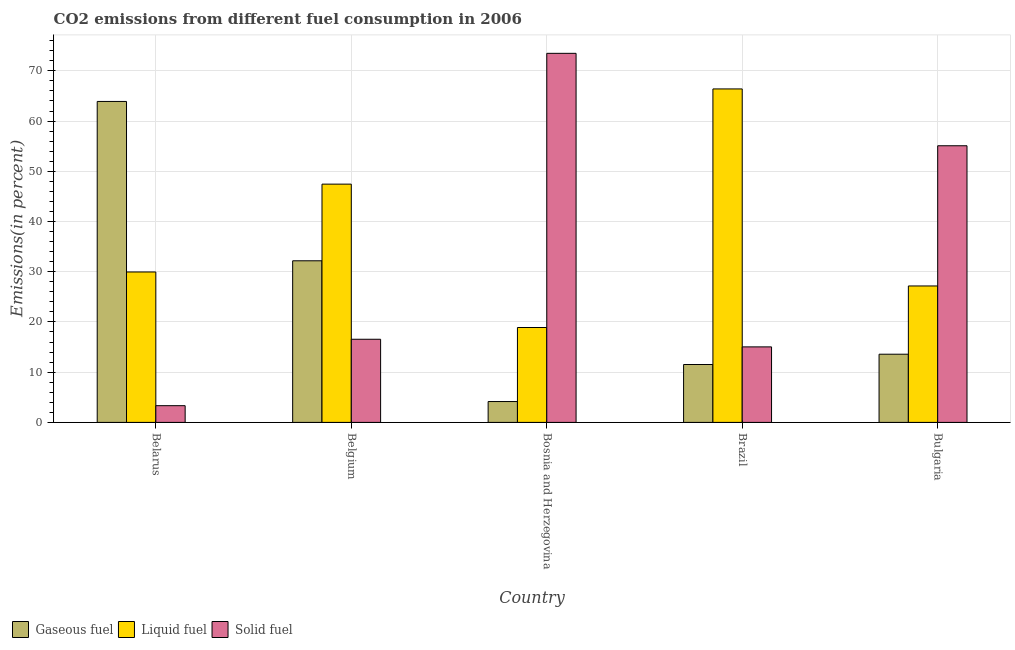How many groups of bars are there?
Your response must be concise. 5. Are the number of bars per tick equal to the number of legend labels?
Provide a short and direct response. Yes. Are the number of bars on each tick of the X-axis equal?
Provide a succinct answer. Yes. What is the label of the 1st group of bars from the left?
Provide a succinct answer. Belarus. In how many cases, is the number of bars for a given country not equal to the number of legend labels?
Keep it short and to the point. 0. What is the percentage of gaseous fuel emission in Belarus?
Your answer should be compact. 63.9. Across all countries, what is the maximum percentage of solid fuel emission?
Make the answer very short. 73.49. Across all countries, what is the minimum percentage of solid fuel emission?
Give a very brief answer. 3.33. In which country was the percentage of gaseous fuel emission maximum?
Offer a terse response. Belarus. In which country was the percentage of solid fuel emission minimum?
Offer a terse response. Belarus. What is the total percentage of gaseous fuel emission in the graph?
Make the answer very short. 125.34. What is the difference between the percentage of liquid fuel emission in Bosnia and Herzegovina and that in Brazil?
Offer a very short reply. -47.5. What is the difference between the percentage of liquid fuel emission in Brazil and the percentage of gaseous fuel emission in Belarus?
Provide a succinct answer. 2.49. What is the average percentage of gaseous fuel emission per country?
Make the answer very short. 25.07. What is the difference between the percentage of gaseous fuel emission and percentage of solid fuel emission in Belarus?
Your response must be concise. 60.58. What is the ratio of the percentage of solid fuel emission in Bosnia and Herzegovina to that in Bulgaria?
Make the answer very short. 1.33. What is the difference between the highest and the second highest percentage of gaseous fuel emission?
Provide a short and direct response. 31.73. What is the difference between the highest and the lowest percentage of solid fuel emission?
Your answer should be compact. 70.16. Is the sum of the percentage of liquid fuel emission in Belarus and Brazil greater than the maximum percentage of gaseous fuel emission across all countries?
Keep it short and to the point. Yes. What does the 2nd bar from the left in Belgium represents?
Your answer should be very brief. Liquid fuel. What does the 1st bar from the right in Belarus represents?
Ensure brevity in your answer.  Solid fuel. Is it the case that in every country, the sum of the percentage of gaseous fuel emission and percentage of liquid fuel emission is greater than the percentage of solid fuel emission?
Offer a terse response. No. How many countries are there in the graph?
Make the answer very short. 5. What is the difference between two consecutive major ticks on the Y-axis?
Ensure brevity in your answer.  10. Are the values on the major ticks of Y-axis written in scientific E-notation?
Your answer should be very brief. No. Does the graph contain any zero values?
Provide a short and direct response. No. What is the title of the graph?
Provide a short and direct response. CO2 emissions from different fuel consumption in 2006. Does "Liquid fuel" appear as one of the legend labels in the graph?
Your response must be concise. Yes. What is the label or title of the X-axis?
Give a very brief answer. Country. What is the label or title of the Y-axis?
Provide a succinct answer. Emissions(in percent). What is the Emissions(in percent) in Gaseous fuel in Belarus?
Make the answer very short. 63.9. What is the Emissions(in percent) of Liquid fuel in Belarus?
Give a very brief answer. 29.95. What is the Emissions(in percent) in Solid fuel in Belarus?
Ensure brevity in your answer.  3.33. What is the Emissions(in percent) of Gaseous fuel in Belgium?
Give a very brief answer. 32.18. What is the Emissions(in percent) in Liquid fuel in Belgium?
Provide a short and direct response. 47.44. What is the Emissions(in percent) in Solid fuel in Belgium?
Your response must be concise. 16.55. What is the Emissions(in percent) of Gaseous fuel in Bosnia and Herzegovina?
Provide a succinct answer. 4.15. What is the Emissions(in percent) in Liquid fuel in Bosnia and Herzegovina?
Make the answer very short. 18.89. What is the Emissions(in percent) in Solid fuel in Bosnia and Herzegovina?
Offer a terse response. 73.49. What is the Emissions(in percent) of Gaseous fuel in Brazil?
Your answer should be very brief. 11.53. What is the Emissions(in percent) of Liquid fuel in Brazil?
Make the answer very short. 66.4. What is the Emissions(in percent) of Solid fuel in Brazil?
Ensure brevity in your answer.  15.03. What is the Emissions(in percent) of Gaseous fuel in Bulgaria?
Your answer should be compact. 13.58. What is the Emissions(in percent) of Liquid fuel in Bulgaria?
Keep it short and to the point. 27.17. What is the Emissions(in percent) in Solid fuel in Bulgaria?
Ensure brevity in your answer.  55.08. Across all countries, what is the maximum Emissions(in percent) of Gaseous fuel?
Keep it short and to the point. 63.9. Across all countries, what is the maximum Emissions(in percent) of Liquid fuel?
Provide a short and direct response. 66.4. Across all countries, what is the maximum Emissions(in percent) of Solid fuel?
Provide a short and direct response. 73.49. Across all countries, what is the minimum Emissions(in percent) in Gaseous fuel?
Ensure brevity in your answer.  4.15. Across all countries, what is the minimum Emissions(in percent) in Liquid fuel?
Your response must be concise. 18.89. Across all countries, what is the minimum Emissions(in percent) of Solid fuel?
Make the answer very short. 3.33. What is the total Emissions(in percent) of Gaseous fuel in the graph?
Your answer should be compact. 125.34. What is the total Emissions(in percent) in Liquid fuel in the graph?
Your response must be concise. 189.85. What is the total Emissions(in percent) in Solid fuel in the graph?
Your answer should be very brief. 163.48. What is the difference between the Emissions(in percent) of Gaseous fuel in Belarus and that in Belgium?
Your answer should be compact. 31.73. What is the difference between the Emissions(in percent) of Liquid fuel in Belarus and that in Belgium?
Provide a short and direct response. -17.49. What is the difference between the Emissions(in percent) of Solid fuel in Belarus and that in Belgium?
Make the answer very short. -13.23. What is the difference between the Emissions(in percent) of Gaseous fuel in Belarus and that in Bosnia and Herzegovina?
Provide a succinct answer. 59.75. What is the difference between the Emissions(in percent) of Liquid fuel in Belarus and that in Bosnia and Herzegovina?
Your answer should be compact. 11.06. What is the difference between the Emissions(in percent) of Solid fuel in Belarus and that in Bosnia and Herzegovina?
Make the answer very short. -70.16. What is the difference between the Emissions(in percent) in Gaseous fuel in Belarus and that in Brazil?
Your answer should be compact. 52.38. What is the difference between the Emissions(in percent) of Liquid fuel in Belarus and that in Brazil?
Your answer should be compact. -36.45. What is the difference between the Emissions(in percent) of Solid fuel in Belarus and that in Brazil?
Make the answer very short. -11.71. What is the difference between the Emissions(in percent) in Gaseous fuel in Belarus and that in Bulgaria?
Make the answer very short. 50.33. What is the difference between the Emissions(in percent) in Liquid fuel in Belarus and that in Bulgaria?
Make the answer very short. 2.78. What is the difference between the Emissions(in percent) of Solid fuel in Belarus and that in Bulgaria?
Your response must be concise. -51.76. What is the difference between the Emissions(in percent) in Gaseous fuel in Belgium and that in Bosnia and Herzegovina?
Offer a very short reply. 28.02. What is the difference between the Emissions(in percent) in Liquid fuel in Belgium and that in Bosnia and Herzegovina?
Provide a succinct answer. 28.55. What is the difference between the Emissions(in percent) in Solid fuel in Belgium and that in Bosnia and Herzegovina?
Offer a terse response. -56.93. What is the difference between the Emissions(in percent) of Gaseous fuel in Belgium and that in Brazil?
Your answer should be compact. 20.65. What is the difference between the Emissions(in percent) in Liquid fuel in Belgium and that in Brazil?
Provide a short and direct response. -18.96. What is the difference between the Emissions(in percent) of Solid fuel in Belgium and that in Brazil?
Offer a terse response. 1.52. What is the difference between the Emissions(in percent) of Gaseous fuel in Belgium and that in Bulgaria?
Ensure brevity in your answer.  18.6. What is the difference between the Emissions(in percent) in Liquid fuel in Belgium and that in Bulgaria?
Your answer should be very brief. 20.27. What is the difference between the Emissions(in percent) of Solid fuel in Belgium and that in Bulgaria?
Ensure brevity in your answer.  -38.53. What is the difference between the Emissions(in percent) of Gaseous fuel in Bosnia and Herzegovina and that in Brazil?
Make the answer very short. -7.37. What is the difference between the Emissions(in percent) of Liquid fuel in Bosnia and Herzegovina and that in Brazil?
Offer a terse response. -47.5. What is the difference between the Emissions(in percent) in Solid fuel in Bosnia and Herzegovina and that in Brazil?
Make the answer very short. 58.45. What is the difference between the Emissions(in percent) of Gaseous fuel in Bosnia and Herzegovina and that in Bulgaria?
Ensure brevity in your answer.  -9.42. What is the difference between the Emissions(in percent) of Liquid fuel in Bosnia and Herzegovina and that in Bulgaria?
Give a very brief answer. -8.27. What is the difference between the Emissions(in percent) in Solid fuel in Bosnia and Herzegovina and that in Bulgaria?
Keep it short and to the point. 18.4. What is the difference between the Emissions(in percent) of Gaseous fuel in Brazil and that in Bulgaria?
Your response must be concise. -2.05. What is the difference between the Emissions(in percent) in Liquid fuel in Brazil and that in Bulgaria?
Your answer should be compact. 39.23. What is the difference between the Emissions(in percent) of Solid fuel in Brazil and that in Bulgaria?
Make the answer very short. -40.05. What is the difference between the Emissions(in percent) in Gaseous fuel in Belarus and the Emissions(in percent) in Liquid fuel in Belgium?
Provide a short and direct response. 16.46. What is the difference between the Emissions(in percent) of Gaseous fuel in Belarus and the Emissions(in percent) of Solid fuel in Belgium?
Provide a short and direct response. 47.35. What is the difference between the Emissions(in percent) of Liquid fuel in Belarus and the Emissions(in percent) of Solid fuel in Belgium?
Offer a very short reply. 13.4. What is the difference between the Emissions(in percent) of Gaseous fuel in Belarus and the Emissions(in percent) of Liquid fuel in Bosnia and Herzegovina?
Your answer should be very brief. 45.01. What is the difference between the Emissions(in percent) of Gaseous fuel in Belarus and the Emissions(in percent) of Solid fuel in Bosnia and Herzegovina?
Provide a short and direct response. -9.58. What is the difference between the Emissions(in percent) in Liquid fuel in Belarus and the Emissions(in percent) in Solid fuel in Bosnia and Herzegovina?
Ensure brevity in your answer.  -43.54. What is the difference between the Emissions(in percent) of Gaseous fuel in Belarus and the Emissions(in percent) of Liquid fuel in Brazil?
Offer a very short reply. -2.49. What is the difference between the Emissions(in percent) of Gaseous fuel in Belarus and the Emissions(in percent) of Solid fuel in Brazil?
Your answer should be compact. 48.87. What is the difference between the Emissions(in percent) in Liquid fuel in Belarus and the Emissions(in percent) in Solid fuel in Brazil?
Offer a terse response. 14.92. What is the difference between the Emissions(in percent) in Gaseous fuel in Belarus and the Emissions(in percent) in Liquid fuel in Bulgaria?
Make the answer very short. 36.74. What is the difference between the Emissions(in percent) in Gaseous fuel in Belarus and the Emissions(in percent) in Solid fuel in Bulgaria?
Give a very brief answer. 8.82. What is the difference between the Emissions(in percent) of Liquid fuel in Belarus and the Emissions(in percent) of Solid fuel in Bulgaria?
Give a very brief answer. -25.13. What is the difference between the Emissions(in percent) of Gaseous fuel in Belgium and the Emissions(in percent) of Liquid fuel in Bosnia and Herzegovina?
Give a very brief answer. 13.29. What is the difference between the Emissions(in percent) in Gaseous fuel in Belgium and the Emissions(in percent) in Solid fuel in Bosnia and Herzegovina?
Provide a short and direct response. -41.31. What is the difference between the Emissions(in percent) of Liquid fuel in Belgium and the Emissions(in percent) of Solid fuel in Bosnia and Herzegovina?
Make the answer very short. -26.05. What is the difference between the Emissions(in percent) in Gaseous fuel in Belgium and the Emissions(in percent) in Liquid fuel in Brazil?
Provide a succinct answer. -34.22. What is the difference between the Emissions(in percent) in Gaseous fuel in Belgium and the Emissions(in percent) in Solid fuel in Brazil?
Offer a very short reply. 17.15. What is the difference between the Emissions(in percent) in Liquid fuel in Belgium and the Emissions(in percent) in Solid fuel in Brazil?
Your response must be concise. 32.41. What is the difference between the Emissions(in percent) of Gaseous fuel in Belgium and the Emissions(in percent) of Liquid fuel in Bulgaria?
Make the answer very short. 5.01. What is the difference between the Emissions(in percent) of Gaseous fuel in Belgium and the Emissions(in percent) of Solid fuel in Bulgaria?
Make the answer very short. -22.9. What is the difference between the Emissions(in percent) of Liquid fuel in Belgium and the Emissions(in percent) of Solid fuel in Bulgaria?
Keep it short and to the point. -7.64. What is the difference between the Emissions(in percent) in Gaseous fuel in Bosnia and Herzegovina and the Emissions(in percent) in Liquid fuel in Brazil?
Ensure brevity in your answer.  -62.24. What is the difference between the Emissions(in percent) of Gaseous fuel in Bosnia and Herzegovina and the Emissions(in percent) of Solid fuel in Brazil?
Provide a succinct answer. -10.88. What is the difference between the Emissions(in percent) of Liquid fuel in Bosnia and Herzegovina and the Emissions(in percent) of Solid fuel in Brazil?
Your response must be concise. 3.86. What is the difference between the Emissions(in percent) of Gaseous fuel in Bosnia and Herzegovina and the Emissions(in percent) of Liquid fuel in Bulgaria?
Provide a succinct answer. -23.01. What is the difference between the Emissions(in percent) of Gaseous fuel in Bosnia and Herzegovina and the Emissions(in percent) of Solid fuel in Bulgaria?
Provide a short and direct response. -50.93. What is the difference between the Emissions(in percent) of Liquid fuel in Bosnia and Herzegovina and the Emissions(in percent) of Solid fuel in Bulgaria?
Provide a succinct answer. -36.19. What is the difference between the Emissions(in percent) of Gaseous fuel in Brazil and the Emissions(in percent) of Liquid fuel in Bulgaria?
Provide a succinct answer. -15.64. What is the difference between the Emissions(in percent) in Gaseous fuel in Brazil and the Emissions(in percent) in Solid fuel in Bulgaria?
Offer a terse response. -43.56. What is the difference between the Emissions(in percent) of Liquid fuel in Brazil and the Emissions(in percent) of Solid fuel in Bulgaria?
Your answer should be very brief. 11.31. What is the average Emissions(in percent) in Gaseous fuel per country?
Your answer should be compact. 25.07. What is the average Emissions(in percent) of Liquid fuel per country?
Your answer should be very brief. 37.97. What is the average Emissions(in percent) of Solid fuel per country?
Make the answer very short. 32.7. What is the difference between the Emissions(in percent) of Gaseous fuel and Emissions(in percent) of Liquid fuel in Belarus?
Your answer should be very brief. 33.95. What is the difference between the Emissions(in percent) in Gaseous fuel and Emissions(in percent) in Solid fuel in Belarus?
Offer a very short reply. 60.58. What is the difference between the Emissions(in percent) in Liquid fuel and Emissions(in percent) in Solid fuel in Belarus?
Offer a very short reply. 26.62. What is the difference between the Emissions(in percent) in Gaseous fuel and Emissions(in percent) in Liquid fuel in Belgium?
Ensure brevity in your answer.  -15.26. What is the difference between the Emissions(in percent) of Gaseous fuel and Emissions(in percent) of Solid fuel in Belgium?
Offer a terse response. 15.63. What is the difference between the Emissions(in percent) of Liquid fuel and Emissions(in percent) of Solid fuel in Belgium?
Give a very brief answer. 30.89. What is the difference between the Emissions(in percent) of Gaseous fuel and Emissions(in percent) of Liquid fuel in Bosnia and Herzegovina?
Keep it short and to the point. -14.74. What is the difference between the Emissions(in percent) of Gaseous fuel and Emissions(in percent) of Solid fuel in Bosnia and Herzegovina?
Your answer should be compact. -69.33. What is the difference between the Emissions(in percent) of Liquid fuel and Emissions(in percent) of Solid fuel in Bosnia and Herzegovina?
Your answer should be compact. -54.59. What is the difference between the Emissions(in percent) of Gaseous fuel and Emissions(in percent) of Liquid fuel in Brazil?
Provide a short and direct response. -54.87. What is the difference between the Emissions(in percent) of Gaseous fuel and Emissions(in percent) of Solid fuel in Brazil?
Provide a short and direct response. -3.51. What is the difference between the Emissions(in percent) in Liquid fuel and Emissions(in percent) in Solid fuel in Brazil?
Ensure brevity in your answer.  51.36. What is the difference between the Emissions(in percent) in Gaseous fuel and Emissions(in percent) in Liquid fuel in Bulgaria?
Your response must be concise. -13.59. What is the difference between the Emissions(in percent) in Gaseous fuel and Emissions(in percent) in Solid fuel in Bulgaria?
Offer a terse response. -41.51. What is the difference between the Emissions(in percent) in Liquid fuel and Emissions(in percent) in Solid fuel in Bulgaria?
Ensure brevity in your answer.  -27.92. What is the ratio of the Emissions(in percent) in Gaseous fuel in Belarus to that in Belgium?
Your response must be concise. 1.99. What is the ratio of the Emissions(in percent) in Liquid fuel in Belarus to that in Belgium?
Give a very brief answer. 0.63. What is the ratio of the Emissions(in percent) in Solid fuel in Belarus to that in Belgium?
Ensure brevity in your answer.  0.2. What is the ratio of the Emissions(in percent) in Gaseous fuel in Belarus to that in Bosnia and Herzegovina?
Offer a terse response. 15.38. What is the ratio of the Emissions(in percent) in Liquid fuel in Belarus to that in Bosnia and Herzegovina?
Make the answer very short. 1.59. What is the ratio of the Emissions(in percent) of Solid fuel in Belarus to that in Bosnia and Herzegovina?
Give a very brief answer. 0.05. What is the ratio of the Emissions(in percent) of Gaseous fuel in Belarus to that in Brazil?
Give a very brief answer. 5.54. What is the ratio of the Emissions(in percent) in Liquid fuel in Belarus to that in Brazil?
Ensure brevity in your answer.  0.45. What is the ratio of the Emissions(in percent) of Solid fuel in Belarus to that in Brazil?
Make the answer very short. 0.22. What is the ratio of the Emissions(in percent) of Gaseous fuel in Belarus to that in Bulgaria?
Offer a terse response. 4.71. What is the ratio of the Emissions(in percent) of Liquid fuel in Belarus to that in Bulgaria?
Your answer should be very brief. 1.1. What is the ratio of the Emissions(in percent) of Solid fuel in Belarus to that in Bulgaria?
Your answer should be compact. 0.06. What is the ratio of the Emissions(in percent) in Gaseous fuel in Belgium to that in Bosnia and Herzegovina?
Provide a short and direct response. 7.75. What is the ratio of the Emissions(in percent) of Liquid fuel in Belgium to that in Bosnia and Herzegovina?
Provide a succinct answer. 2.51. What is the ratio of the Emissions(in percent) of Solid fuel in Belgium to that in Bosnia and Herzegovina?
Your answer should be very brief. 0.23. What is the ratio of the Emissions(in percent) of Gaseous fuel in Belgium to that in Brazil?
Make the answer very short. 2.79. What is the ratio of the Emissions(in percent) of Liquid fuel in Belgium to that in Brazil?
Provide a short and direct response. 0.71. What is the ratio of the Emissions(in percent) in Solid fuel in Belgium to that in Brazil?
Your response must be concise. 1.1. What is the ratio of the Emissions(in percent) of Gaseous fuel in Belgium to that in Bulgaria?
Your response must be concise. 2.37. What is the ratio of the Emissions(in percent) of Liquid fuel in Belgium to that in Bulgaria?
Provide a succinct answer. 1.75. What is the ratio of the Emissions(in percent) of Solid fuel in Belgium to that in Bulgaria?
Your answer should be very brief. 0.3. What is the ratio of the Emissions(in percent) in Gaseous fuel in Bosnia and Herzegovina to that in Brazil?
Provide a short and direct response. 0.36. What is the ratio of the Emissions(in percent) of Liquid fuel in Bosnia and Herzegovina to that in Brazil?
Your answer should be compact. 0.28. What is the ratio of the Emissions(in percent) in Solid fuel in Bosnia and Herzegovina to that in Brazil?
Give a very brief answer. 4.89. What is the ratio of the Emissions(in percent) in Gaseous fuel in Bosnia and Herzegovina to that in Bulgaria?
Keep it short and to the point. 0.31. What is the ratio of the Emissions(in percent) of Liquid fuel in Bosnia and Herzegovina to that in Bulgaria?
Your answer should be very brief. 0.7. What is the ratio of the Emissions(in percent) in Solid fuel in Bosnia and Herzegovina to that in Bulgaria?
Make the answer very short. 1.33. What is the ratio of the Emissions(in percent) in Gaseous fuel in Brazil to that in Bulgaria?
Keep it short and to the point. 0.85. What is the ratio of the Emissions(in percent) in Liquid fuel in Brazil to that in Bulgaria?
Provide a succinct answer. 2.44. What is the ratio of the Emissions(in percent) in Solid fuel in Brazil to that in Bulgaria?
Make the answer very short. 0.27. What is the difference between the highest and the second highest Emissions(in percent) of Gaseous fuel?
Provide a succinct answer. 31.73. What is the difference between the highest and the second highest Emissions(in percent) of Liquid fuel?
Ensure brevity in your answer.  18.96. What is the difference between the highest and the second highest Emissions(in percent) of Solid fuel?
Give a very brief answer. 18.4. What is the difference between the highest and the lowest Emissions(in percent) in Gaseous fuel?
Ensure brevity in your answer.  59.75. What is the difference between the highest and the lowest Emissions(in percent) in Liquid fuel?
Offer a very short reply. 47.5. What is the difference between the highest and the lowest Emissions(in percent) of Solid fuel?
Provide a short and direct response. 70.16. 